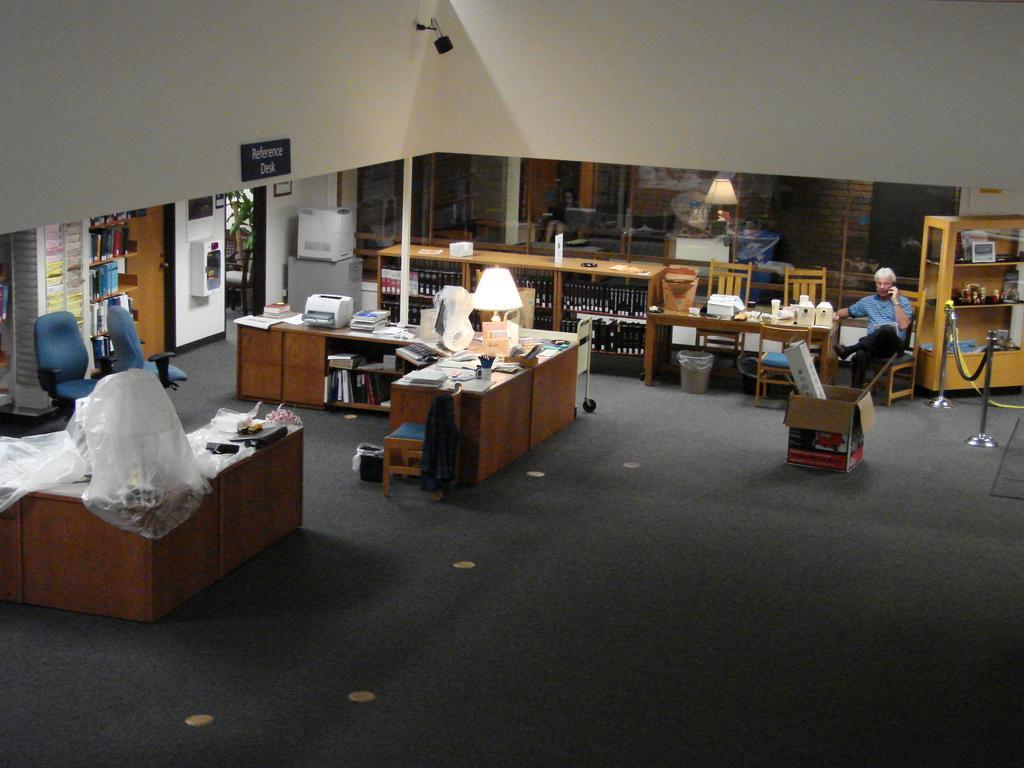How would you summarize this image in a sentence or two? The image consists of man sitting on chair at right side corner and there are many racks,books,lamps all over,it's all looking messy. It seems to be office area and there is a security camera over the top. 